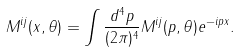<formula> <loc_0><loc_0><loc_500><loc_500>M ^ { i j } ( x , \theta ) = \int \frac { d ^ { 4 } p } { ( 2 \pi ) ^ { 4 } } M ^ { i j } ( p , \theta ) e ^ { - i p x } .</formula> 